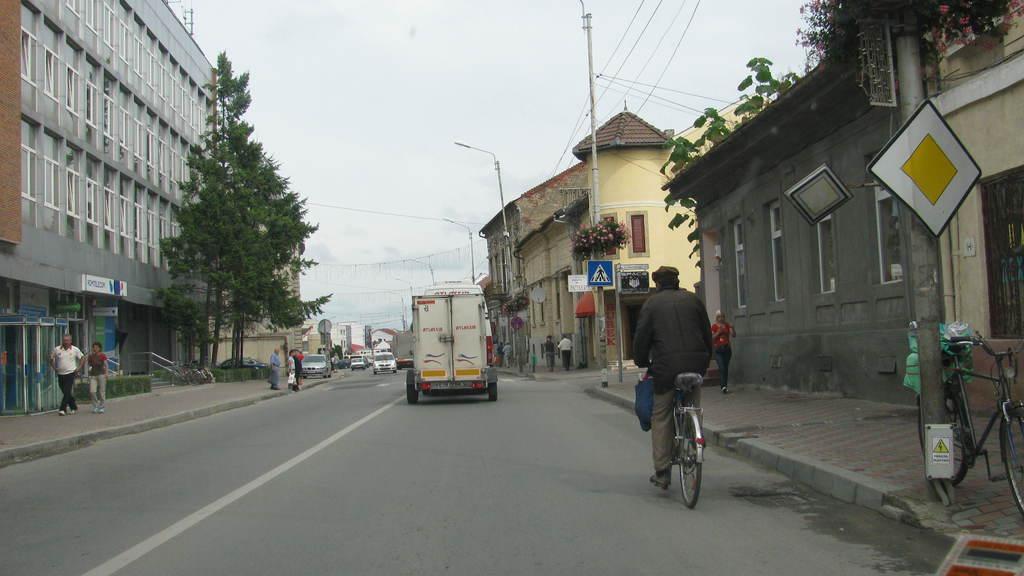In one or two sentences, can you explain what this image depicts? In this picture I can see there is a street and there are vehicles moving on the road and there is a person riding the bicycle and on the walk way there are few people walking. There are buildings on both side of the roads and there are street light poles and the sky is clear. 